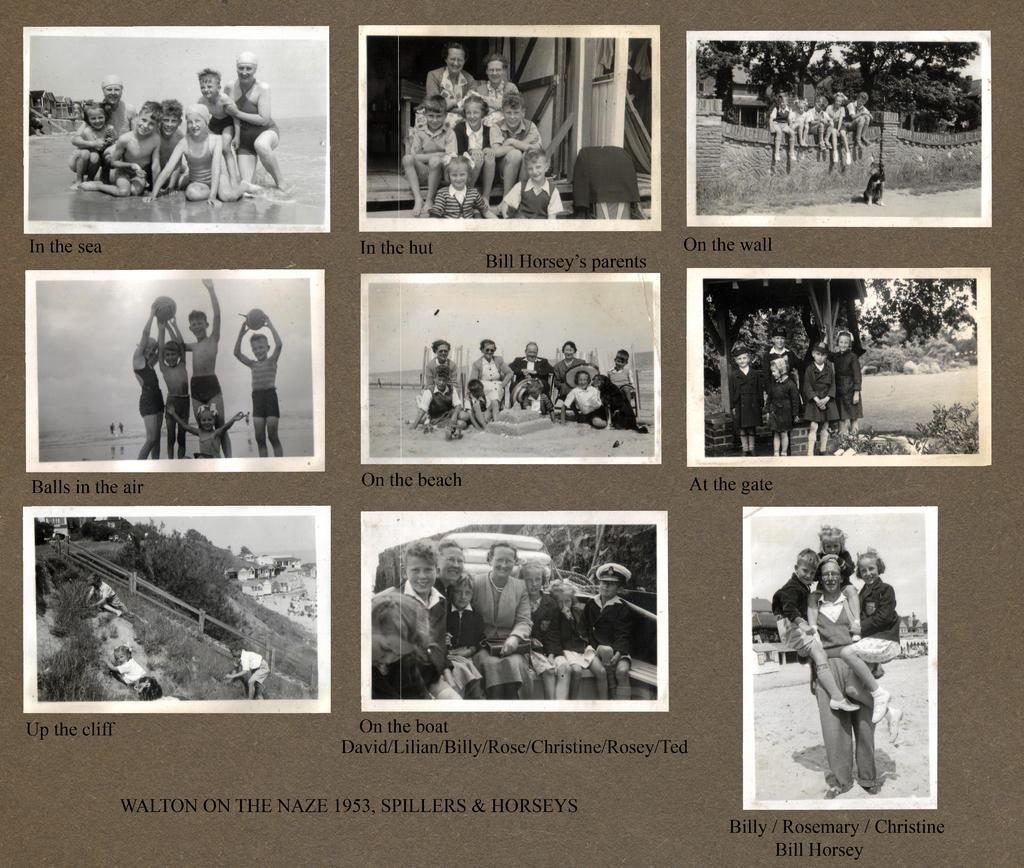In one or two sentences, can you explain what this image depicts? This image consists of a poster with a few images of kids, men and women and there is a text on it. In this image there are a few images. There are a few trees and plants. There is a wall and a few kids are sitting on the wall and a few are playing with a ball. 